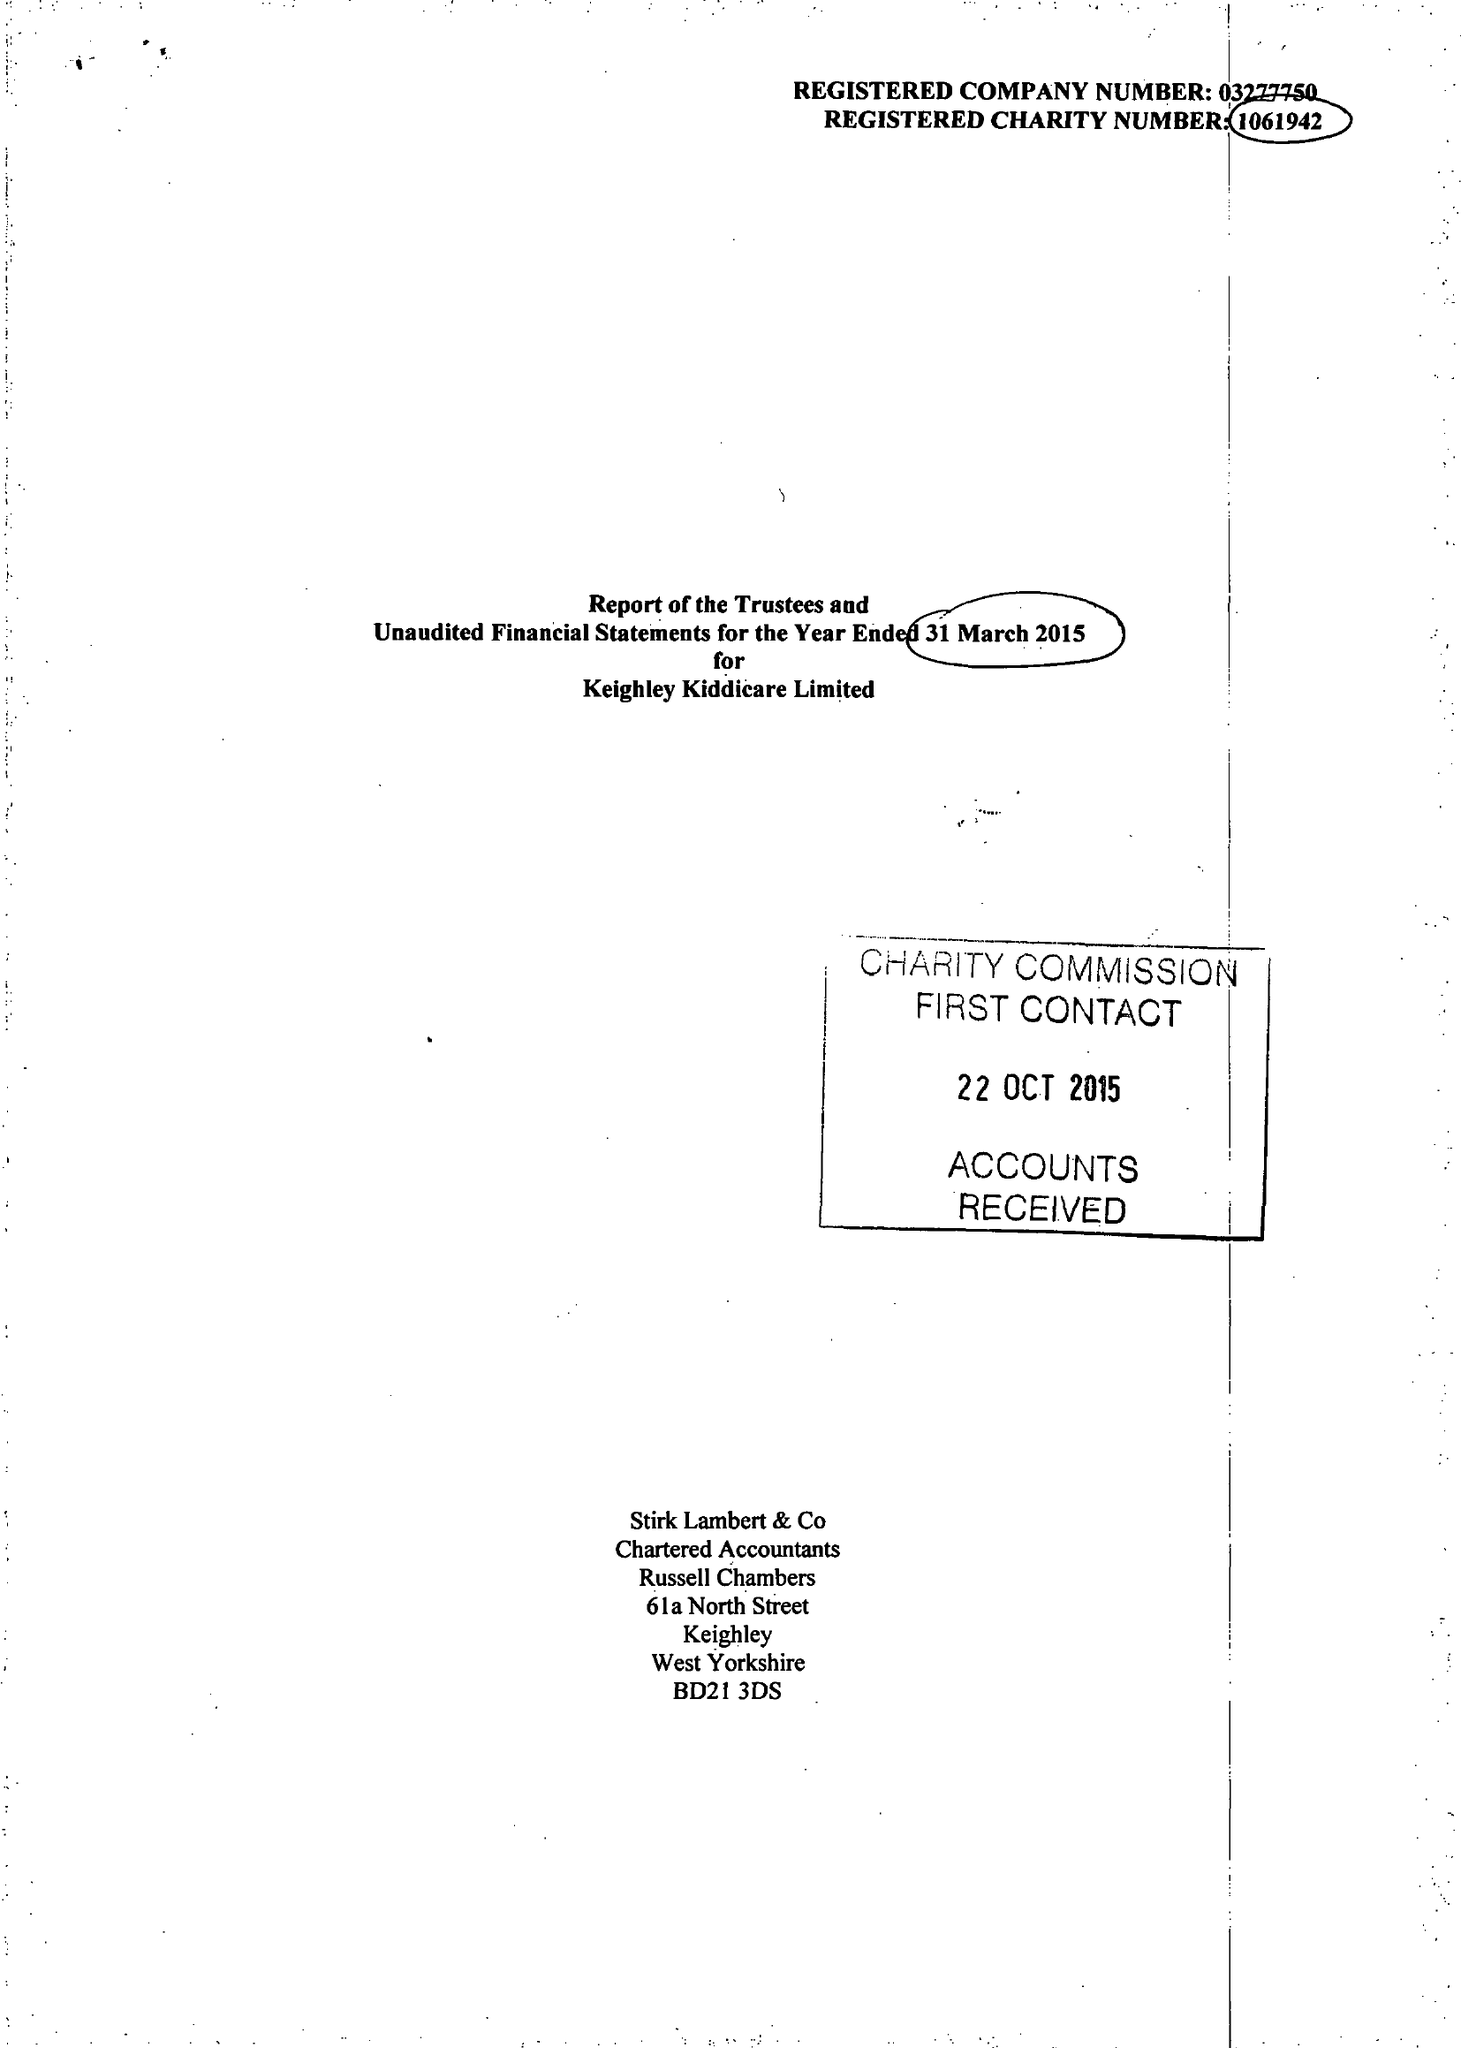What is the value for the address__street_line?
Answer the question using a single word or phrase. None 